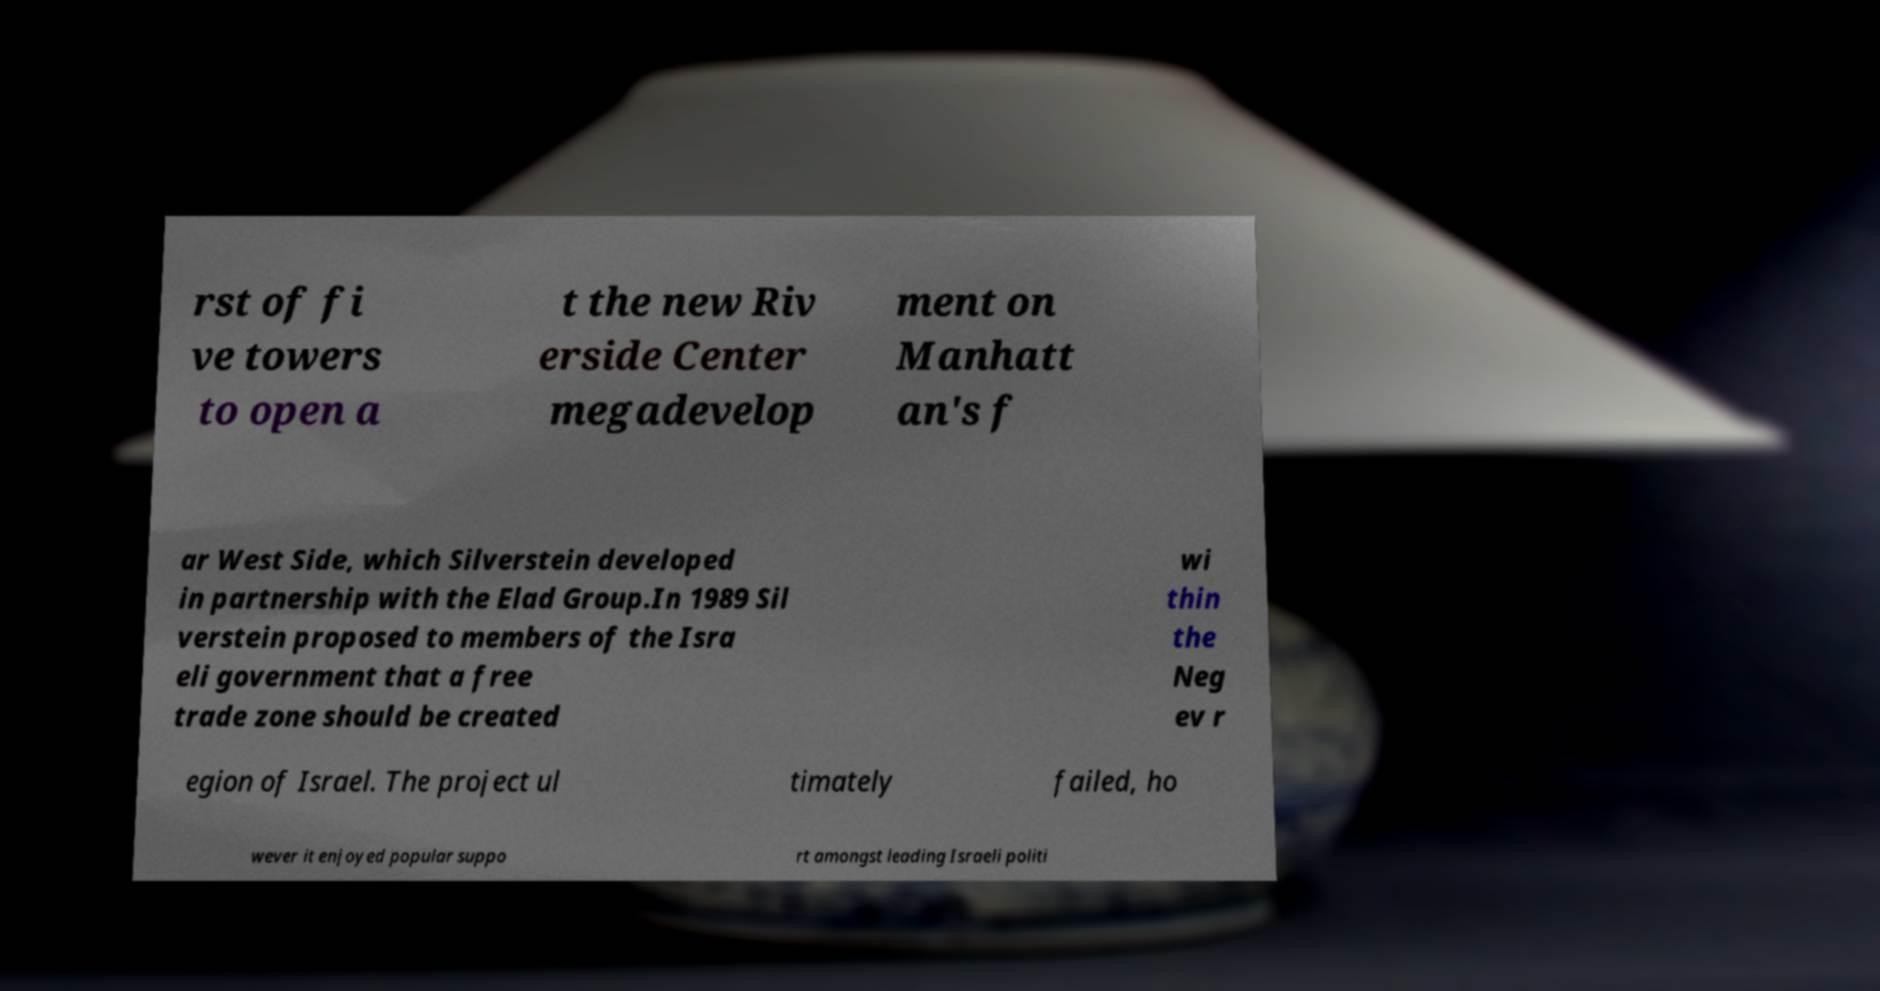Could you assist in decoding the text presented in this image and type it out clearly? rst of fi ve towers to open a t the new Riv erside Center megadevelop ment on Manhatt an's f ar West Side, which Silverstein developed in partnership with the Elad Group.In 1989 Sil verstein proposed to members of the Isra eli government that a free trade zone should be created wi thin the Neg ev r egion of Israel. The project ul timately failed, ho wever it enjoyed popular suppo rt amongst leading Israeli politi 